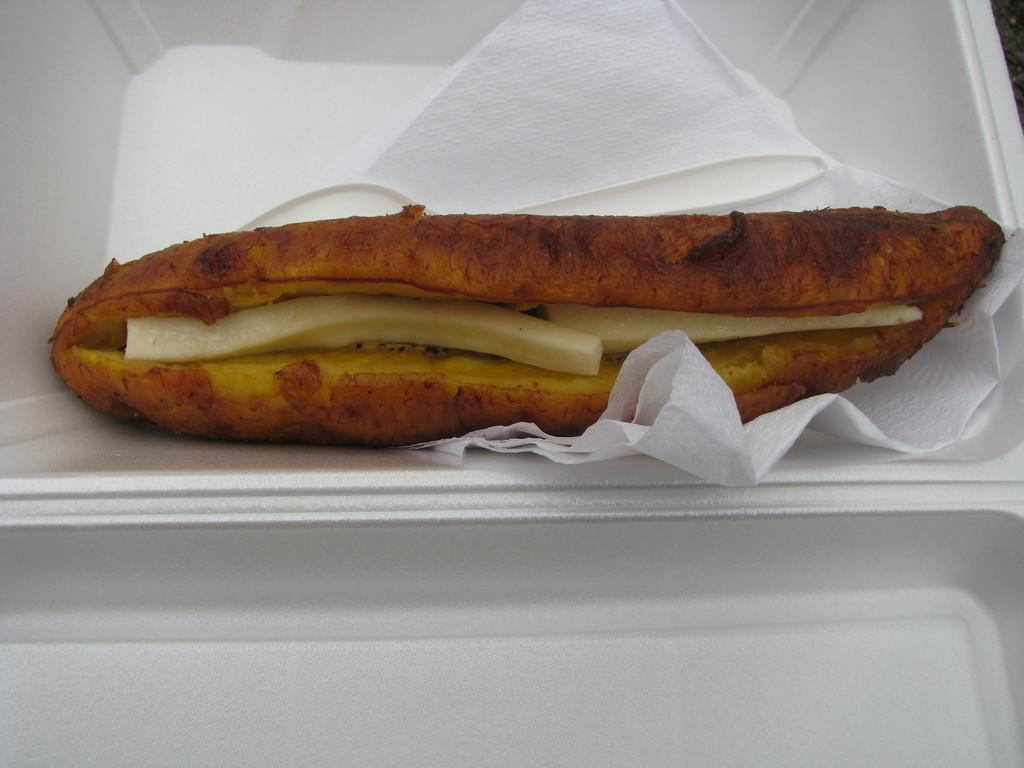What type of item can be seen in the image that is meant to be eaten? There is an edible item in the image. What else is present in the image besides the edible item? There are tissue papers in the image. How might the edible item and tissue papers be arranged or contained in the image? The edible item and tissue papers might be placed in a white box or tray. What color is the background of the image? The background of the image is white. What type of map can be seen in the image? There is no map present in the image. What kind of nut is placed in the basket in the image? There is no nut or basket present in the image. 